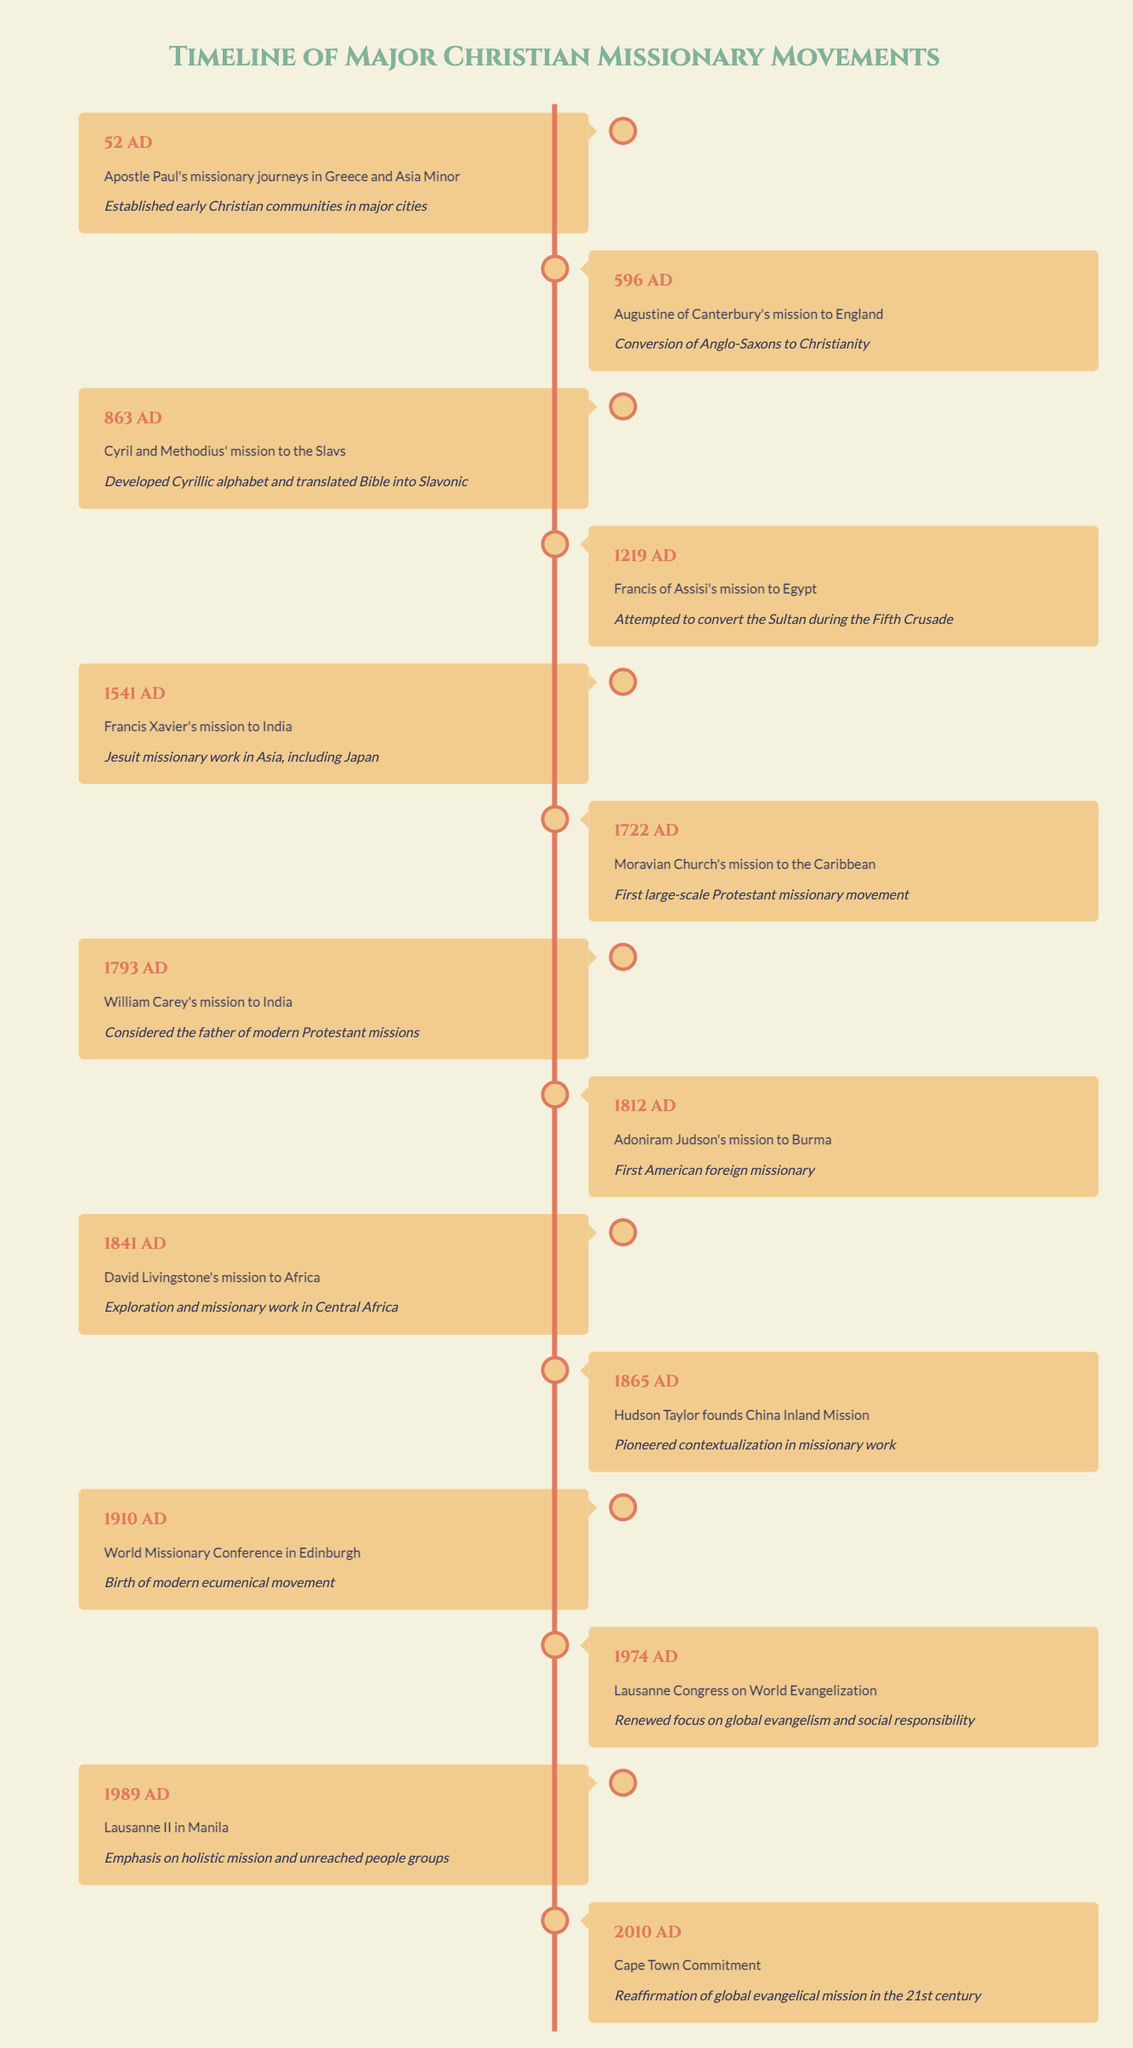What year did Apostle Paul begin his missionary journeys? According to the table, Apostle Paul's missionary journeys began in the year 52. The year is specifically stated in the first entry of the timeline.
Answer: 52 AD What significant achievement is associated with Cyril and Methodius' mission? The significance associated with Cyril and Methodius' mission to the Slavs in 863 is that they developed the Cyrillic alphabet and translated the Bible into Slavonic. This is mentioned in the significance column for that event.
Answer: Developed Cyrillic alphabet and translated the Bible into Slavonic Which missionary movement is considered the first large-scale Protestant missionary movement? The Moravian Church's mission to the Caribbean in 1722 is recognized as the first large-scale Protestant missionary movement, as indicated in its significance description within the timeline.
Answer: Moravian Church's mission to the Caribbean How many years passed between the mission of Augustine of Canterbury and the World Missionary Conference in Edinburgh? To calculate the number of years, subtract the year of Augustine of Canterbury's mission (596) from the year of the World Missionary Conference (1910): 1910 - 596 = 1314 years. Therefore, 1314 years passed between these two events.
Answer: 1314 years Was Francis Xavier known for his missionary work in Asia? Yes, the significance of Francis Xavier's mission to India in 1541 states that he was involved in Jesuit missionary work in Asia, which includes Japan. This confirms that he was indeed known for his work in Asia.
Answer: Yes Which event is noted for emphasizing holistic mission and unreached people groups? The event that is noted for this emphasis is Lausanne II in Manila in 1989, as stated in its significance within the timeline. This indicates a clear focus on holistic mission and attention to unreached groups.
Answer: Lausanne II in Manila What was the purpose of the Lausanne Congress on World Evangelization held in 1974? The purpose of the Lausanne Congress on World Evangelization was to renew focus on global evangelism and social responsibility, as highlighted in the significance of that particular event in the table.
Answer: Renewed focus on global evangelism and social responsibility How many notable missionary events occurred before the 19th century? Counting the events listed prior to the 19th century (1793), we find events from the years 52, 596, 863, 1219, 1541, 1722, and 1793. Thus, there are a total of 7 notable missionary events before the 19th century.
Answer: 7 events Which missionary movement pioneered contextualization in missionary work? The China Inland Mission founded by Hudson Taylor in 1865 is noted for pioneering contextualization in missionary work, as detailed in the significance of that event.
Answer: China Inland Mission 